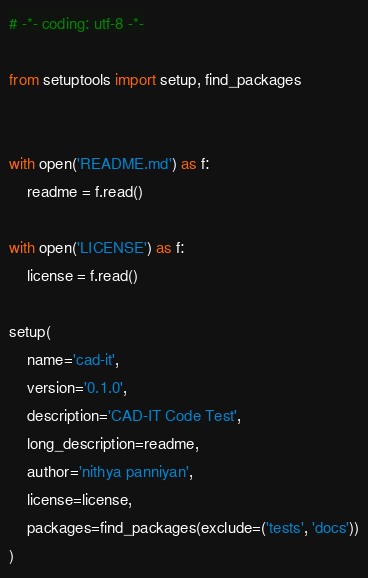Convert code to text. <code><loc_0><loc_0><loc_500><loc_500><_Python_># -*- coding: utf-8 -*-

from setuptools import setup, find_packages


with open('README.md') as f:
    readme = f.read()

with open('LICENSE') as f:
    license = f.read()

setup(
    name='cad-it',
    version='0.1.0',
    description='CAD-IT Code Test',
    long_description=readme,
    author='nithya panniyan',
    license=license,
    packages=find_packages(exclude=('tests', 'docs'))
)

</code> 